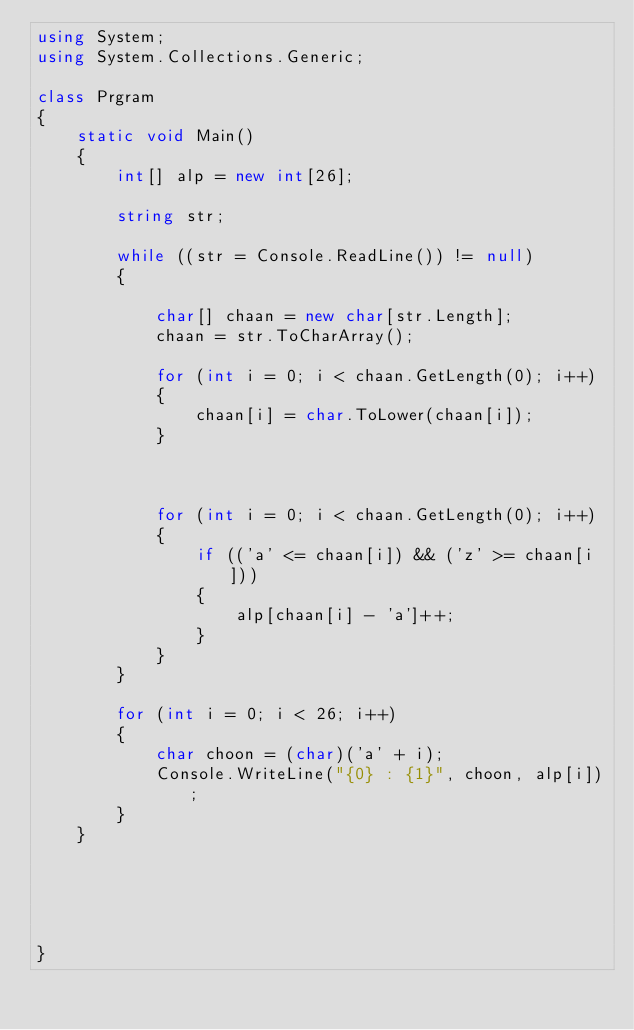<code> <loc_0><loc_0><loc_500><loc_500><_C#_>using System;
using System.Collections.Generic;

class Prgram
{
    static void Main()
    {
        int[] alp = new int[26];

        string str;

        while ((str = Console.ReadLine()) != null)
        {
           
            char[] chaan = new char[str.Length];
            chaan = str.ToCharArray();

            for (int i = 0; i < chaan.GetLength(0); i++)
            {
                chaan[i] = char.ToLower(chaan[i]);
            }



            for (int i = 0; i < chaan.GetLength(0); i++)
            {
                if (('a' <= chaan[i]) && ('z' >= chaan[i]))
                {
                    alp[chaan[i] - 'a']++;
                }
            }
        }

        for (int i = 0; i < 26; i++)
        {
            char choon = (char)('a' + i);
            Console.WriteLine("{0} : {1}", choon, alp[i]);
        }
    }

   

 
    
}</code> 